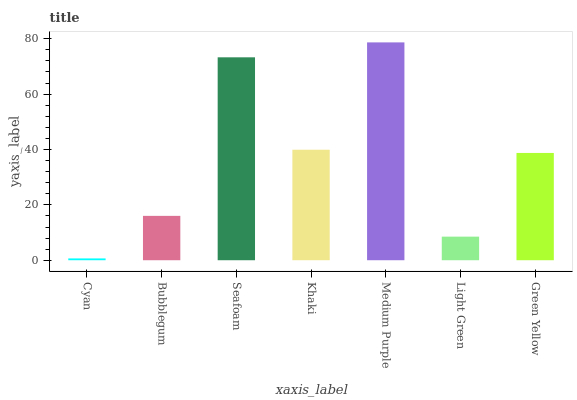Is Cyan the minimum?
Answer yes or no. Yes. Is Medium Purple the maximum?
Answer yes or no. Yes. Is Bubblegum the minimum?
Answer yes or no. No. Is Bubblegum the maximum?
Answer yes or no. No. Is Bubblegum greater than Cyan?
Answer yes or no. Yes. Is Cyan less than Bubblegum?
Answer yes or no. Yes. Is Cyan greater than Bubblegum?
Answer yes or no. No. Is Bubblegum less than Cyan?
Answer yes or no. No. Is Green Yellow the high median?
Answer yes or no. Yes. Is Green Yellow the low median?
Answer yes or no. Yes. Is Bubblegum the high median?
Answer yes or no. No. Is Bubblegum the low median?
Answer yes or no. No. 